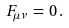Convert formula to latex. <formula><loc_0><loc_0><loc_500><loc_500>F _ { \mu \nu } \, = \, 0 \, .</formula> 